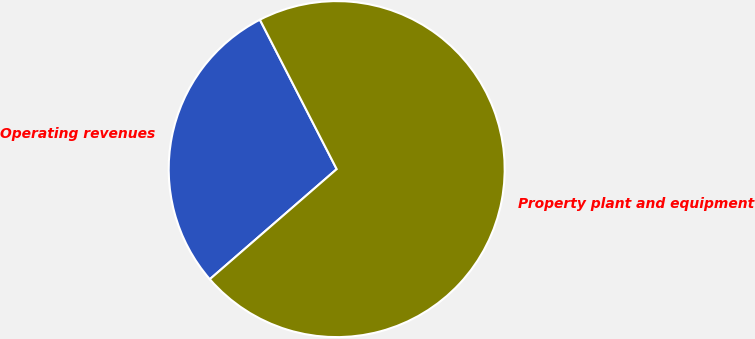Convert chart. <chart><loc_0><loc_0><loc_500><loc_500><pie_chart><fcel>Operating revenues<fcel>Property plant and equipment<nl><fcel>28.82%<fcel>71.18%<nl></chart> 